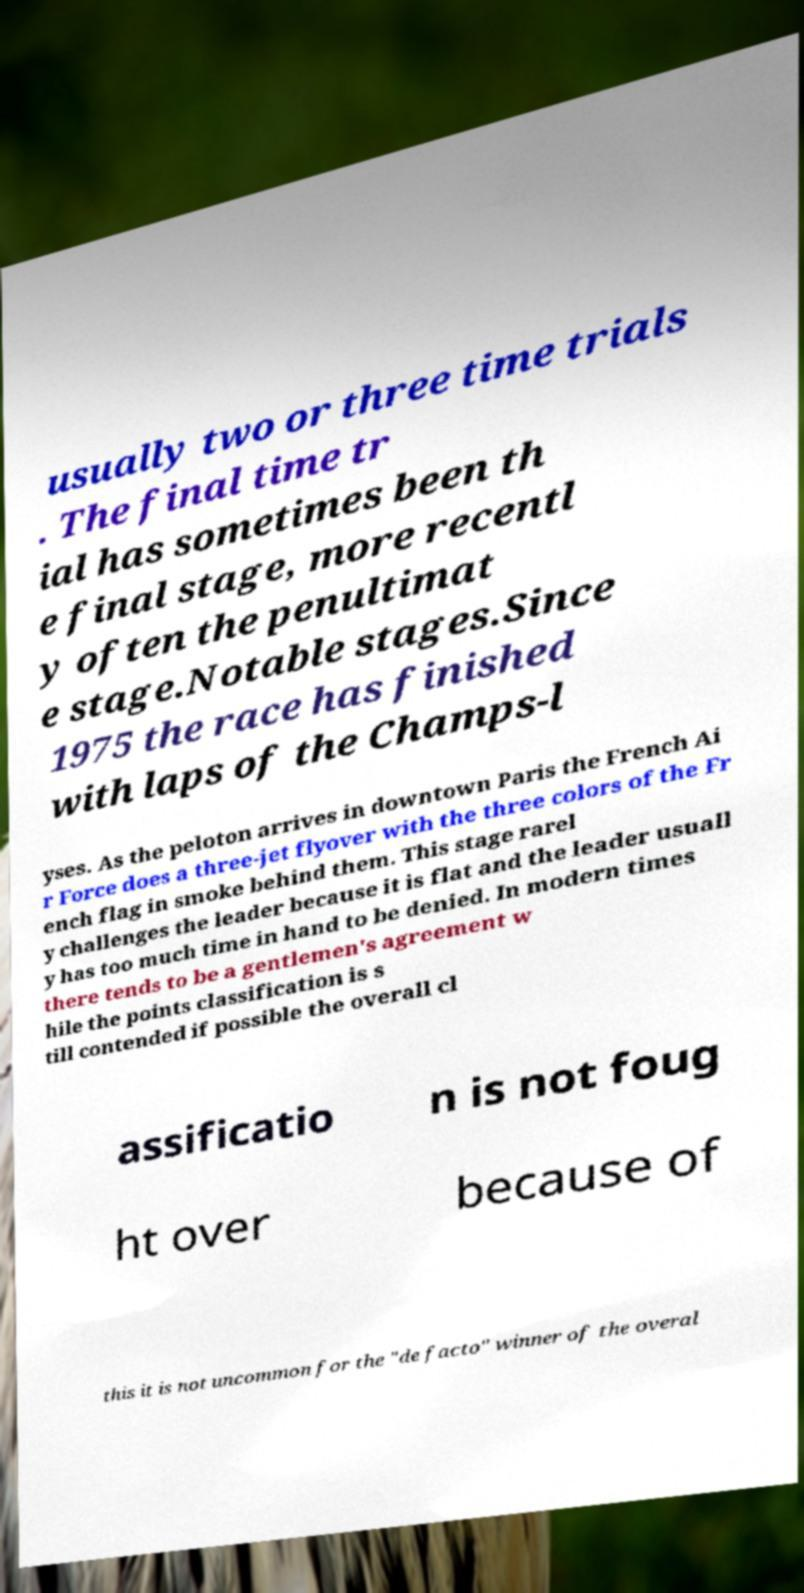Can you accurately transcribe the text from the provided image for me? usually two or three time trials . The final time tr ial has sometimes been th e final stage, more recentl y often the penultimat e stage.Notable stages.Since 1975 the race has finished with laps of the Champs-l yses. As the peloton arrives in downtown Paris the French Ai r Force does a three-jet flyover with the three colors of the Fr ench flag in smoke behind them. This stage rarel y challenges the leader because it is flat and the leader usuall y has too much time in hand to be denied. In modern times there tends to be a gentlemen's agreement w hile the points classification is s till contended if possible the overall cl assificatio n is not foug ht over because of this it is not uncommon for the "de facto" winner of the overal 